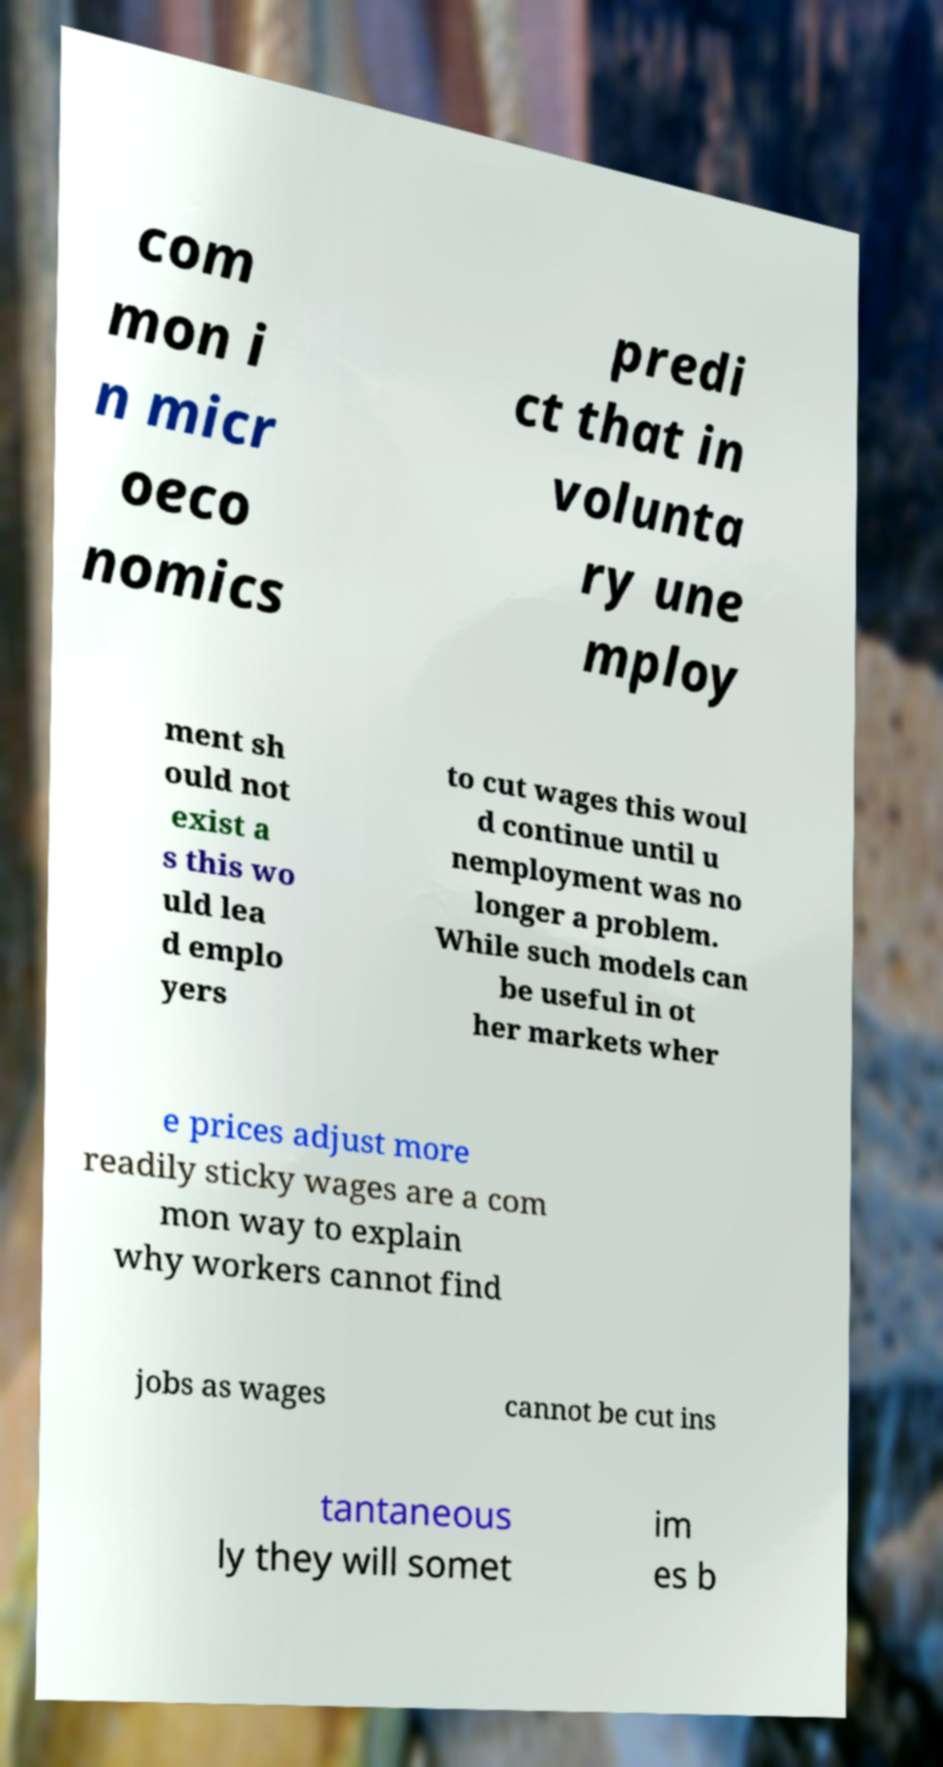Could you extract and type out the text from this image? com mon i n micr oeco nomics predi ct that in volunta ry une mploy ment sh ould not exist a s this wo uld lea d emplo yers to cut wages this woul d continue until u nemployment was no longer a problem. While such models can be useful in ot her markets wher e prices adjust more readily sticky wages are a com mon way to explain why workers cannot find jobs as wages cannot be cut ins tantaneous ly they will somet im es b 